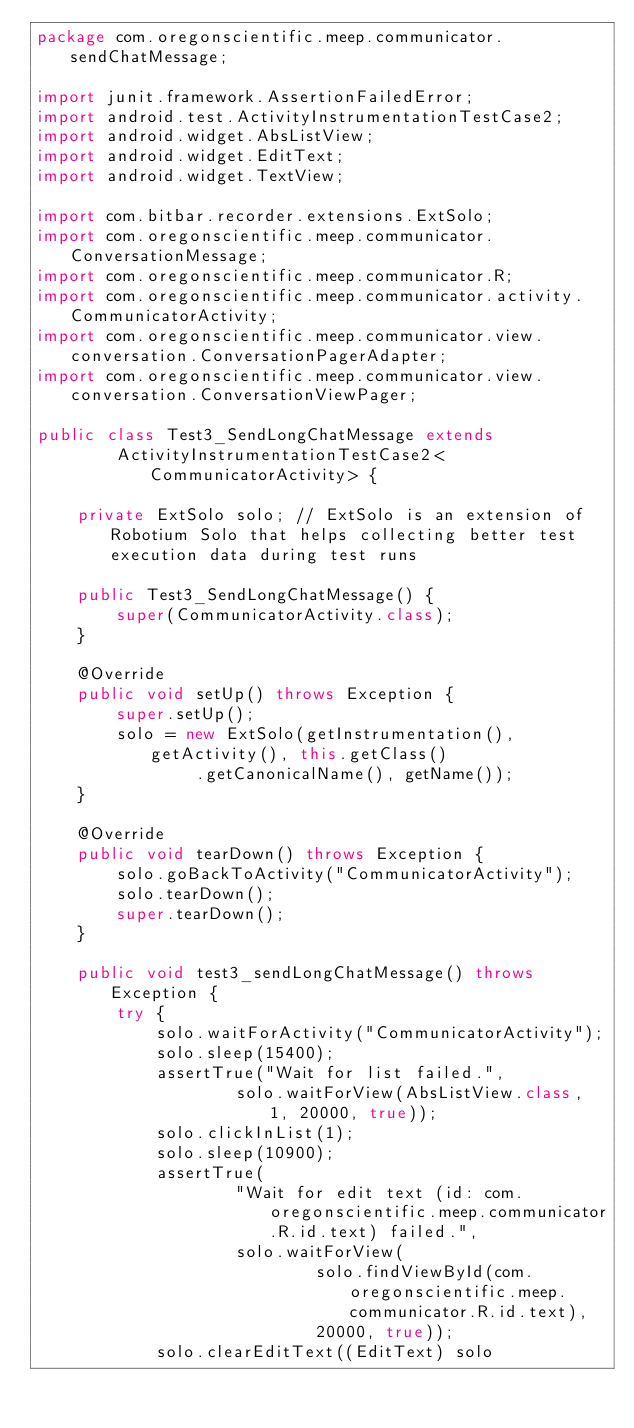Convert code to text. <code><loc_0><loc_0><loc_500><loc_500><_Java_>package com.oregonscientific.meep.communicator.sendChatMessage;

import junit.framework.AssertionFailedError;
import android.test.ActivityInstrumentationTestCase2;
import android.widget.AbsListView;
import android.widget.EditText;
import android.widget.TextView;

import com.bitbar.recorder.extensions.ExtSolo;
import com.oregonscientific.meep.communicator.ConversationMessage;
import com.oregonscientific.meep.communicator.R;
import com.oregonscientific.meep.communicator.activity.CommunicatorActivity;
import com.oregonscientific.meep.communicator.view.conversation.ConversationPagerAdapter;
import com.oregonscientific.meep.communicator.view.conversation.ConversationViewPager;

public class Test3_SendLongChatMessage extends
		ActivityInstrumentationTestCase2<CommunicatorActivity> {

	private ExtSolo solo; // ExtSolo is an extension of Robotium Solo that helps collecting better test execution data during test runs

	public Test3_SendLongChatMessage() {
		super(CommunicatorActivity.class);
	}

	@Override
	public void setUp() throws Exception {
		super.setUp();
		solo = new ExtSolo(getInstrumentation(), getActivity(), this.getClass()
				.getCanonicalName(), getName());
	}

	@Override
	public void tearDown() throws Exception {
		solo.goBackToActivity("CommunicatorActivity");
		solo.tearDown();
		super.tearDown();
	}

	public void test3_sendLongChatMessage() throws Exception {
		try {
			solo.waitForActivity("CommunicatorActivity");
			solo.sleep(15400);
			assertTrue("Wait for list failed.",
					solo.waitForView(AbsListView.class, 1, 20000, true));
			solo.clickInList(1);
			solo.sleep(10900);
			assertTrue(
					"Wait for edit text (id: com.oregonscientific.meep.communicator.R.id.text) failed.",
					solo.waitForView(
							solo.findViewById(com.oregonscientific.meep.communicator.R.id.text),
							20000, true));
			solo.clearEditText((EditText) solo</code> 